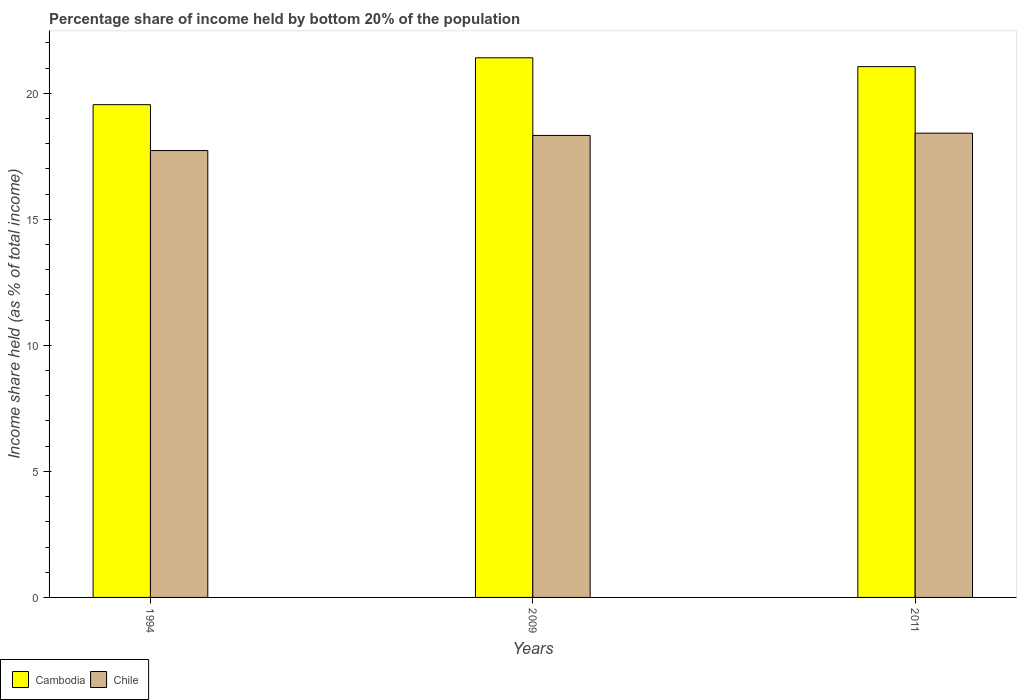How many different coloured bars are there?
Your response must be concise. 2. How many groups of bars are there?
Your response must be concise. 3. In how many cases, is the number of bars for a given year not equal to the number of legend labels?
Provide a short and direct response. 0. What is the share of income held by bottom 20% of the population in Cambodia in 2009?
Give a very brief answer. 21.41. Across all years, what is the maximum share of income held by bottom 20% of the population in Chile?
Offer a terse response. 18.42. Across all years, what is the minimum share of income held by bottom 20% of the population in Cambodia?
Offer a terse response. 19.55. In which year was the share of income held by bottom 20% of the population in Cambodia maximum?
Ensure brevity in your answer.  2009. In which year was the share of income held by bottom 20% of the population in Chile minimum?
Your answer should be very brief. 1994. What is the total share of income held by bottom 20% of the population in Cambodia in the graph?
Offer a very short reply. 62.02. What is the difference between the share of income held by bottom 20% of the population in Chile in 1994 and that in 2011?
Offer a very short reply. -0.69. What is the difference between the share of income held by bottom 20% of the population in Cambodia in 2011 and the share of income held by bottom 20% of the population in Chile in 2009?
Your answer should be compact. 2.73. What is the average share of income held by bottom 20% of the population in Cambodia per year?
Make the answer very short. 20.67. In the year 2009, what is the difference between the share of income held by bottom 20% of the population in Cambodia and share of income held by bottom 20% of the population in Chile?
Your response must be concise. 3.08. What is the ratio of the share of income held by bottom 20% of the population in Cambodia in 1994 to that in 2009?
Your answer should be very brief. 0.91. Is the share of income held by bottom 20% of the population in Cambodia in 1994 less than that in 2009?
Offer a terse response. Yes. What is the difference between the highest and the second highest share of income held by bottom 20% of the population in Chile?
Your answer should be very brief. 0.09. What is the difference between the highest and the lowest share of income held by bottom 20% of the population in Chile?
Give a very brief answer. 0.69. In how many years, is the share of income held by bottom 20% of the population in Chile greater than the average share of income held by bottom 20% of the population in Chile taken over all years?
Your answer should be very brief. 2. Is the sum of the share of income held by bottom 20% of the population in Cambodia in 1994 and 2011 greater than the maximum share of income held by bottom 20% of the population in Chile across all years?
Your answer should be compact. Yes. What does the 2nd bar from the left in 2011 represents?
Provide a succinct answer. Chile. What does the 2nd bar from the right in 2009 represents?
Offer a very short reply. Cambodia. How many bars are there?
Offer a very short reply. 6. Are all the bars in the graph horizontal?
Offer a terse response. No. What is the title of the graph?
Offer a terse response. Percentage share of income held by bottom 20% of the population. Does "Zimbabwe" appear as one of the legend labels in the graph?
Offer a very short reply. No. What is the label or title of the X-axis?
Provide a short and direct response. Years. What is the label or title of the Y-axis?
Give a very brief answer. Income share held (as % of total income). What is the Income share held (as % of total income) of Cambodia in 1994?
Offer a very short reply. 19.55. What is the Income share held (as % of total income) in Chile in 1994?
Offer a very short reply. 17.73. What is the Income share held (as % of total income) of Cambodia in 2009?
Ensure brevity in your answer.  21.41. What is the Income share held (as % of total income) of Chile in 2009?
Your answer should be very brief. 18.33. What is the Income share held (as % of total income) in Cambodia in 2011?
Your response must be concise. 21.06. What is the Income share held (as % of total income) of Chile in 2011?
Give a very brief answer. 18.42. Across all years, what is the maximum Income share held (as % of total income) in Cambodia?
Offer a very short reply. 21.41. Across all years, what is the maximum Income share held (as % of total income) of Chile?
Your response must be concise. 18.42. Across all years, what is the minimum Income share held (as % of total income) in Cambodia?
Keep it short and to the point. 19.55. Across all years, what is the minimum Income share held (as % of total income) of Chile?
Your response must be concise. 17.73. What is the total Income share held (as % of total income) in Cambodia in the graph?
Make the answer very short. 62.02. What is the total Income share held (as % of total income) of Chile in the graph?
Give a very brief answer. 54.48. What is the difference between the Income share held (as % of total income) of Cambodia in 1994 and that in 2009?
Make the answer very short. -1.86. What is the difference between the Income share held (as % of total income) of Cambodia in 1994 and that in 2011?
Your answer should be compact. -1.51. What is the difference between the Income share held (as % of total income) in Chile in 1994 and that in 2011?
Offer a terse response. -0.69. What is the difference between the Income share held (as % of total income) in Chile in 2009 and that in 2011?
Your answer should be compact. -0.09. What is the difference between the Income share held (as % of total income) of Cambodia in 1994 and the Income share held (as % of total income) of Chile in 2009?
Provide a short and direct response. 1.22. What is the difference between the Income share held (as % of total income) of Cambodia in 1994 and the Income share held (as % of total income) of Chile in 2011?
Your response must be concise. 1.13. What is the difference between the Income share held (as % of total income) of Cambodia in 2009 and the Income share held (as % of total income) of Chile in 2011?
Offer a terse response. 2.99. What is the average Income share held (as % of total income) of Cambodia per year?
Provide a succinct answer. 20.67. What is the average Income share held (as % of total income) in Chile per year?
Offer a very short reply. 18.16. In the year 1994, what is the difference between the Income share held (as % of total income) of Cambodia and Income share held (as % of total income) of Chile?
Keep it short and to the point. 1.82. In the year 2009, what is the difference between the Income share held (as % of total income) in Cambodia and Income share held (as % of total income) in Chile?
Provide a succinct answer. 3.08. In the year 2011, what is the difference between the Income share held (as % of total income) in Cambodia and Income share held (as % of total income) in Chile?
Give a very brief answer. 2.64. What is the ratio of the Income share held (as % of total income) in Cambodia in 1994 to that in 2009?
Offer a terse response. 0.91. What is the ratio of the Income share held (as % of total income) of Chile in 1994 to that in 2009?
Make the answer very short. 0.97. What is the ratio of the Income share held (as % of total income) of Cambodia in 1994 to that in 2011?
Your response must be concise. 0.93. What is the ratio of the Income share held (as % of total income) of Chile in 1994 to that in 2011?
Give a very brief answer. 0.96. What is the ratio of the Income share held (as % of total income) of Cambodia in 2009 to that in 2011?
Offer a very short reply. 1.02. What is the difference between the highest and the second highest Income share held (as % of total income) of Cambodia?
Offer a very short reply. 0.35. What is the difference between the highest and the second highest Income share held (as % of total income) of Chile?
Offer a very short reply. 0.09. What is the difference between the highest and the lowest Income share held (as % of total income) of Cambodia?
Your answer should be very brief. 1.86. What is the difference between the highest and the lowest Income share held (as % of total income) in Chile?
Your response must be concise. 0.69. 